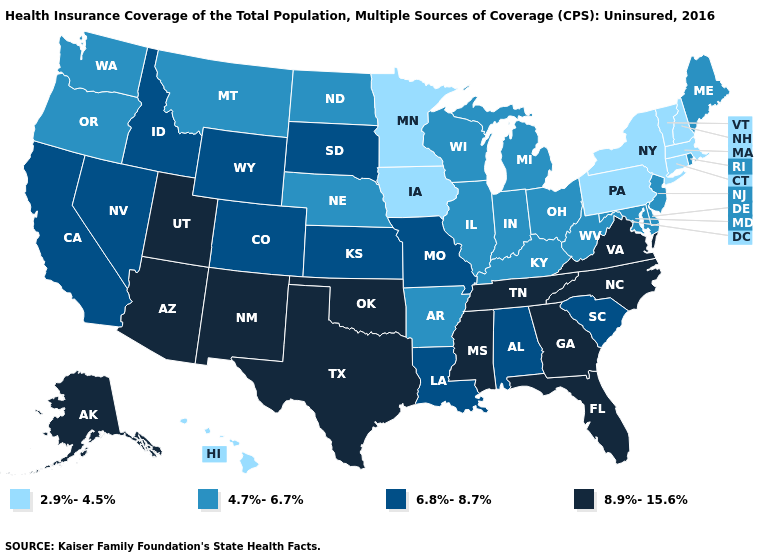What is the value of Arizona?
Short answer required. 8.9%-15.6%. What is the highest value in the USA?
Keep it brief. 8.9%-15.6%. Does North Carolina have the highest value in the South?
Concise answer only. Yes. Name the states that have a value in the range 2.9%-4.5%?
Concise answer only. Connecticut, Hawaii, Iowa, Massachusetts, Minnesota, New Hampshire, New York, Pennsylvania, Vermont. What is the value of Delaware?
Concise answer only. 4.7%-6.7%. What is the value of Alabama?
Concise answer only. 6.8%-8.7%. Name the states that have a value in the range 8.9%-15.6%?
Write a very short answer. Alaska, Arizona, Florida, Georgia, Mississippi, New Mexico, North Carolina, Oklahoma, Tennessee, Texas, Utah, Virginia. What is the value of New Hampshire?
Concise answer only. 2.9%-4.5%. How many symbols are there in the legend?
Answer briefly. 4. What is the value of Texas?
Concise answer only. 8.9%-15.6%. What is the value of Oklahoma?
Give a very brief answer. 8.9%-15.6%. What is the highest value in states that border Delaware?
Keep it brief. 4.7%-6.7%. Does Utah have a lower value than Arizona?
Concise answer only. No. Among the states that border Delaware , does Maryland have the lowest value?
Answer briefly. No. 